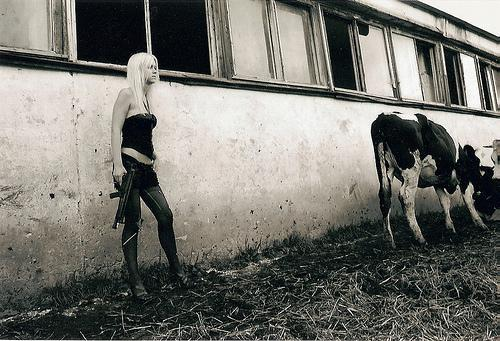Question: what animal is shown?
Choices:
A. A cow.
B. A horse.
C. A pig.
D. A sheep.
Answer with the letter. Answer: A Question: what gender is the person?
Choices:
A. Male.
B. Intersex.
C. Genderqueer.
D. A female.
Answer with the letter. Answer: D Question: who is holding the gun?
Choices:
A. A man.
B. A woman.
C. A child.
D. A teenager.
Answer with the letter. Answer: B 